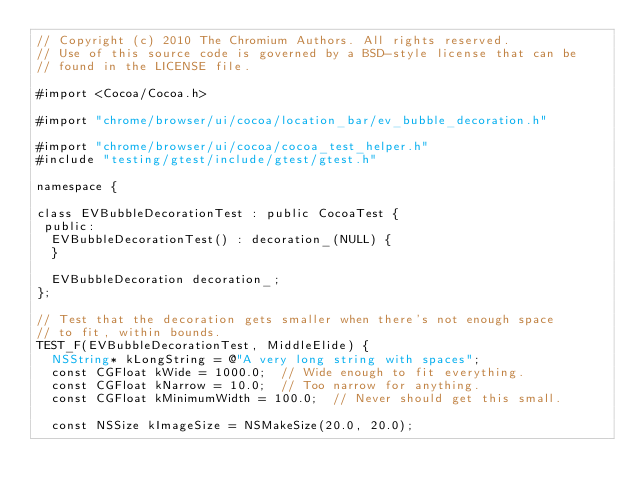<code> <loc_0><loc_0><loc_500><loc_500><_ObjectiveC_>// Copyright (c) 2010 The Chromium Authors. All rights reserved.
// Use of this source code is governed by a BSD-style license that can be
// found in the LICENSE file.

#import <Cocoa/Cocoa.h>

#import "chrome/browser/ui/cocoa/location_bar/ev_bubble_decoration.h"

#import "chrome/browser/ui/cocoa/cocoa_test_helper.h"
#include "testing/gtest/include/gtest/gtest.h"

namespace {

class EVBubbleDecorationTest : public CocoaTest {
 public:
  EVBubbleDecorationTest() : decoration_(NULL) {
  }

  EVBubbleDecoration decoration_;
};

// Test that the decoration gets smaller when there's not enough space
// to fit, within bounds.
TEST_F(EVBubbleDecorationTest, MiddleElide) {
  NSString* kLongString = @"A very long string with spaces";
  const CGFloat kWide = 1000.0;  // Wide enough to fit everything.
  const CGFloat kNarrow = 10.0;  // Too narrow for anything.
  const CGFloat kMinimumWidth = 100.0;  // Never should get this small.

  const NSSize kImageSize = NSMakeSize(20.0, 20.0);</code> 